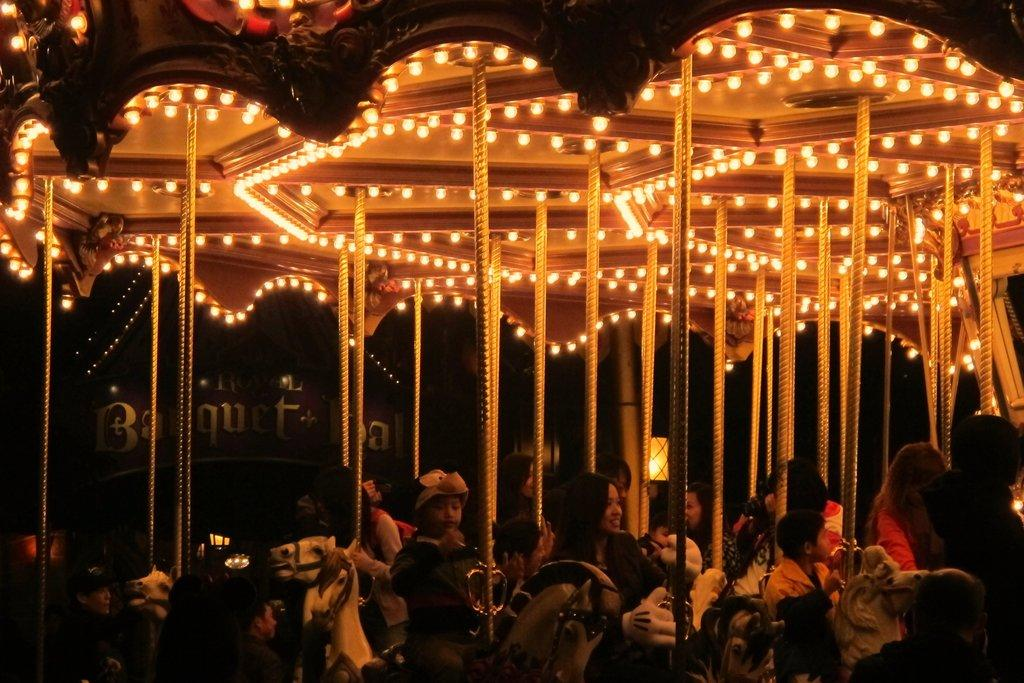What is the main subject of the image? There is a carousel in the image. What can be seen at the top of the carousel? There are lights at the top of the carousel. What are the children doing in the image? The children are playing on the carousel. What is the lighting condition in the image? The image was clicked in the dark. What type of cabbage is being used as a payment method for the carousel ride? There is no cabbage present in the image, nor is there any indication of a payment method for the carousel ride. What kind of apparatus is being used by the children to play on the carousel? The children are playing on the carousel itself, which is the main subject of the image. There is no additional apparatus mentioned or visible in the image. 